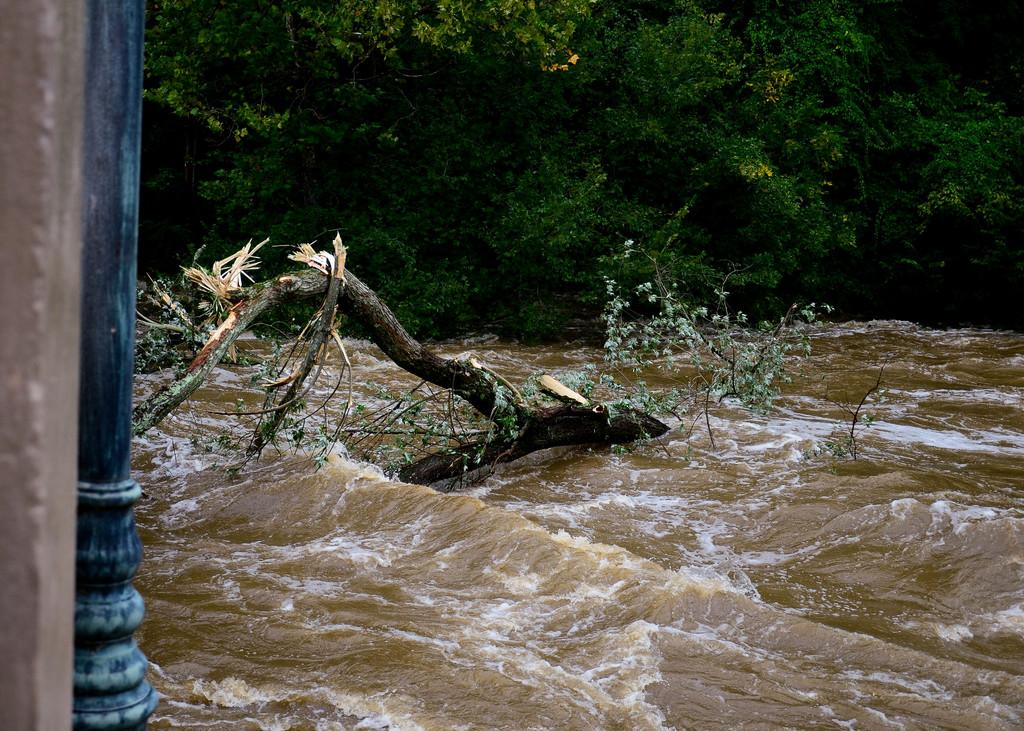What is located in the water in the image? There is a tree trunk in the water. What can be seen around the tree trunk in the water? There are trees visible around the tree trunk. What other object can be seen in the image? There is a pole in the image. What type of toys are floating in the water near the tree trunk? There are no toys present in the image; it only features a tree trunk in the water, trees around it, and a pole. 